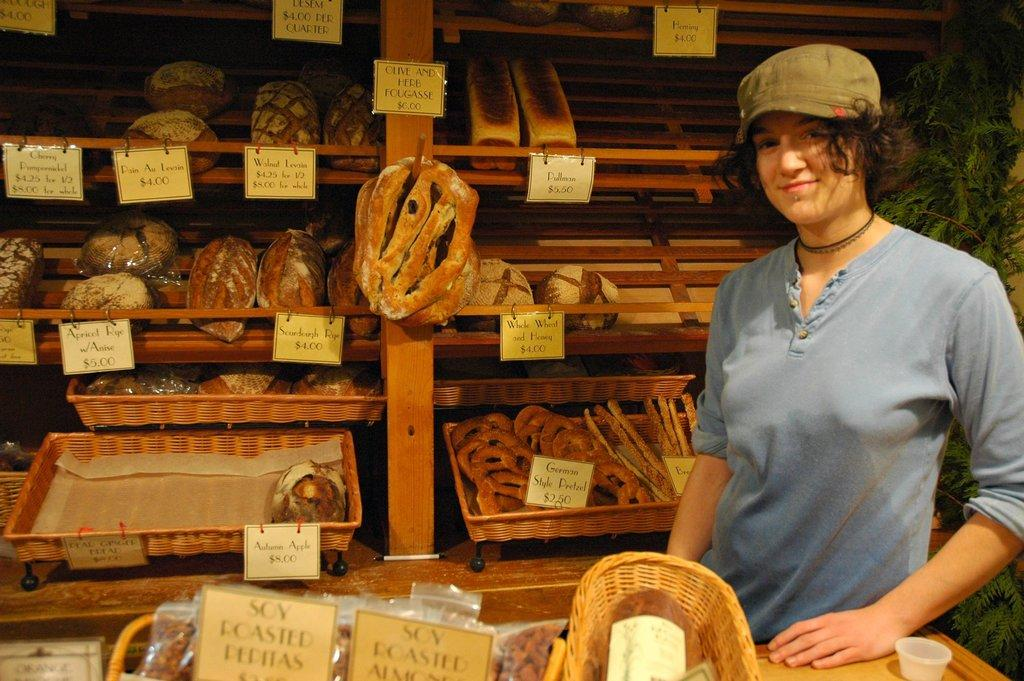<image>
Render a clear and concise summary of the photo. Posing for a picture in a bakery where German style pretzels are only $2.50. 